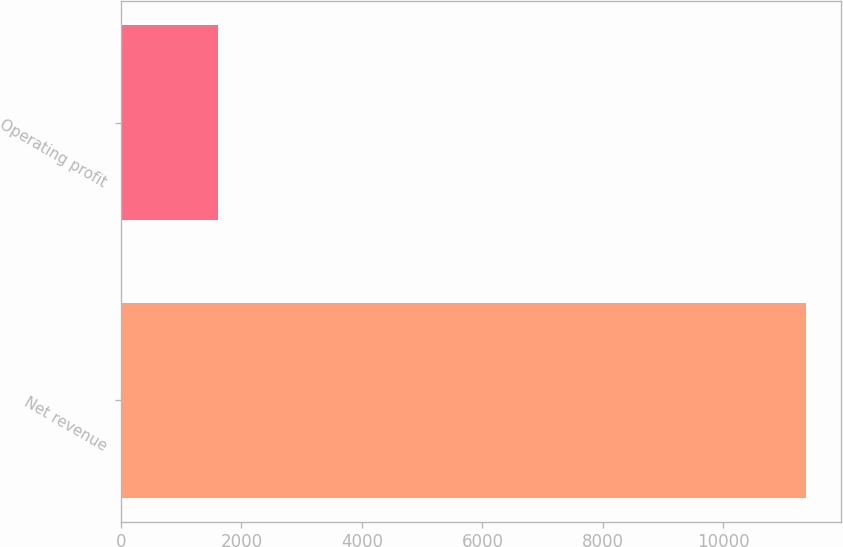Convert chart to OTSL. <chart><loc_0><loc_0><loc_500><loc_500><bar_chart><fcel>Net revenue<fcel>Operating profit<nl><fcel>11376<fcel>1607<nl></chart> 